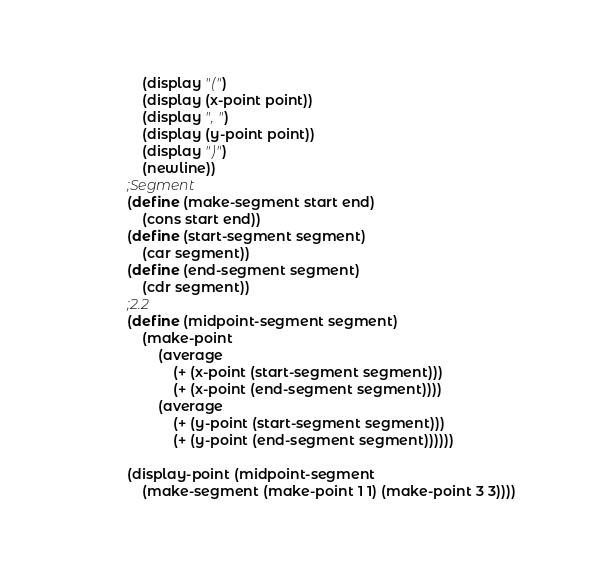<code> <loc_0><loc_0><loc_500><loc_500><_Scheme_>    (display "(")
    (display (x-point point))
    (display ", ")
    (display (y-point point))
    (display ")")
    (newline))
;Segment
(define (make-segment start end)
    (cons start end))
(define (start-segment segment)
    (car segment))
(define (end-segment segment)
    (cdr segment))
;2.2
(define (midpoint-segment segment)
    (make-point 
        (average 
            (+ (x-point (start-segment segment)))
            (+ (x-point (end-segment segment))))
        (average 
            (+ (y-point (start-segment segment)))
            (+ (y-point (end-segment segment))))))

(display-point (midpoint-segment 
    (make-segment (make-point 1 1) (make-point 3 3))))</code> 